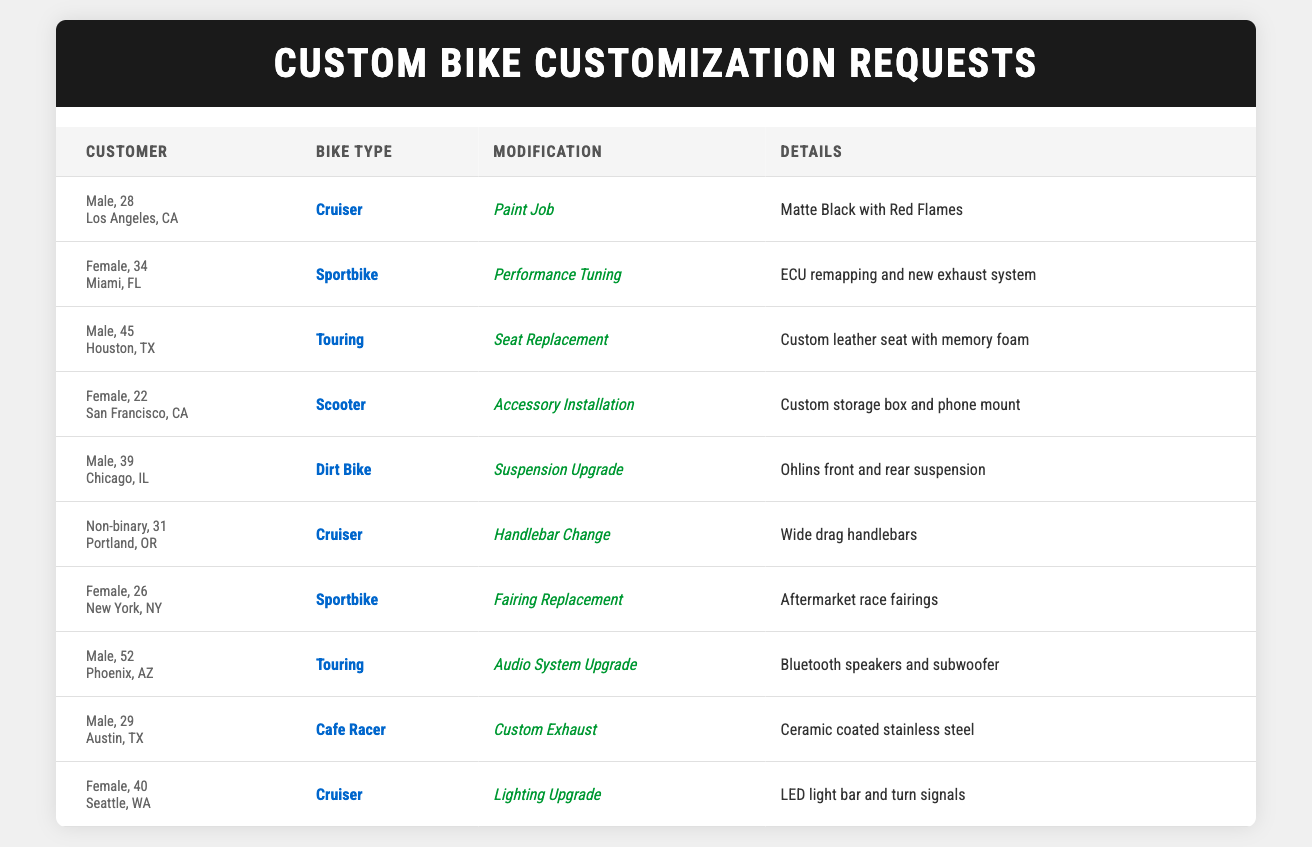What is the most common bike type among the customization requests? By inspecting the bike types listed in the table, the requests for "Cruiser" appear three times, while "Sportbike" and "Touring" appear two times each. Therefore, "Cruiser" is the most common bike type among the requests.
Answer: Cruiser How many male customers requested a modification for their bike? Counting the entries in the table, there are five male customers (customer IDs 1, 3, 5, 8, and 9) who made customization requests.
Answer: 5 Is there a specific modification type that female customers preferred more than others? In the table, female customers requested three different types of modifications: "Performance Tuning," "Accessory Installation," and "Fairing Replacement." There doesn't seem to be a single preferred type, as each type was requested by one female customer.
Answer: No What is the age of the customer who made the request for "Audio System Upgrade"? The customization request for "Audio System Upgrade" is made by the customer aged 52 (customer ID 8).
Answer: 52 Among the customization requests, how many pertain to Cruisers and what specific modifications were made? There are three requests for Cruisers (customer IDs 1, 6, and 10). The modifications are "Paint Job," "Handlebar Change," and "Lighting Upgrade," respectively.
Answer: 3 requests; Paint Job, Handlebar Change, Lighting Upgrade Which modification type is the least represented in the table? Scanning the table, we note that "Performance Tuning," "Accessory Installation," and "Custom Exhaust" each only appear once. Therefore, they are tied as the least represented modification types.
Answer: Performance Tuning, Accessory Installation, Custom Exhaust What percentage of the total customization requests involve sportbikes? There are two sportbike requests out of a total of 10 requests. Calculating the percentage: (2/10) * 100 = 20%.
Answer: 20% Which city has the highest number of customization requests, and how many are there? By reviewing the data, Los Angeles, CA, has one request; Miami, FL, has one; Houston, TX, has one; San Francisco, CA, has one; Chicago, IL, has one; Portland, OR, has one; New York, NY, has one; Phoenix, AZ, has one; Austin, TX, has one; and Seattle, WA, has one. All cities have only one request, so there is no highest number.
Answer: No city has a higher number; all are one How many different modification types are requested in total? Upon categorizing the modification types listed in the table, we identify the following distinct types: "Paint Job," "Performance Tuning," "Seat Replacement," "Accessory Installation," "Suspension Upgrade," "Handlebar Change," "Fairing Replacement," "Audio System Upgrade," "Custom Exhaust," and "Lighting Upgrade." That makes a total of 10 different modification types.
Answer: 10 What is the average age of customers who requested "Cruiser" modifications? The ages of customers requesting Cruiser modifications are 28 (customer 1), 31 (customer 6), and 40 (customer 10). Adding these up gives 28 + 31 + 40 = 99. Dividing by the number of customers (3): 99/3 = 33.
Answer: 33 